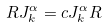Convert formula to latex. <formula><loc_0><loc_0><loc_500><loc_500>R J ^ { \alpha } _ { k } = c J ^ { \alpha } _ { k } R</formula> 